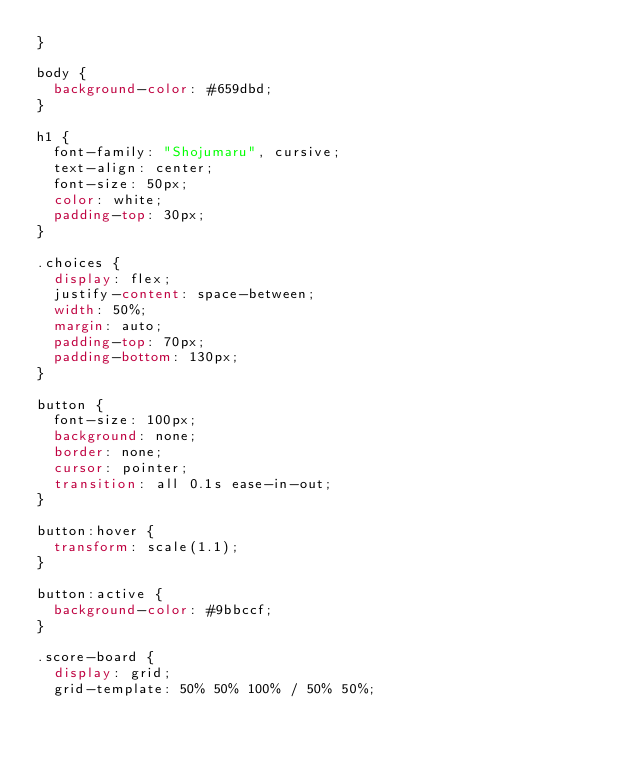Convert code to text. <code><loc_0><loc_0><loc_500><loc_500><_CSS_>}

body {
  background-color: #659dbd;
}

h1 {
  font-family: "Shojumaru", cursive;
  text-align: center;
  font-size: 50px;
  color: white;
  padding-top: 30px;
}

.choices {
  display: flex;
  justify-content: space-between;
  width: 50%;
  margin: auto;
  padding-top: 70px;
  padding-bottom: 130px;
}

button {
  font-size: 100px;
  background: none;
  border: none;
  cursor: pointer;
  transition: all 0.1s ease-in-out;
}

button:hover {
  transform: scale(1.1);
}

button:active {
  background-color: #9bbccf;
}

.score-board {
  display: grid;
  grid-template: 50% 50% 100% / 50% 50%;</code> 